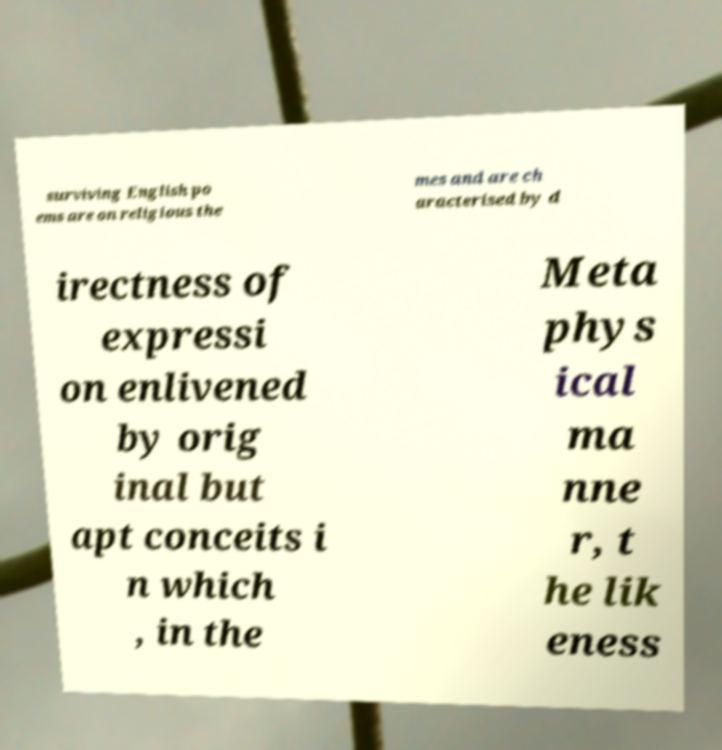For documentation purposes, I need the text within this image transcribed. Could you provide that? surviving English po ems are on religious the mes and are ch aracterised by d irectness of expressi on enlivened by orig inal but apt conceits i n which , in the Meta phys ical ma nne r, t he lik eness 